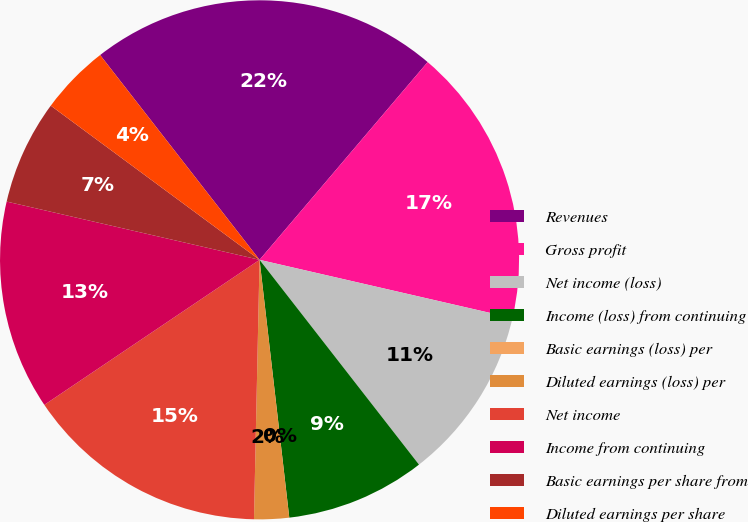Convert chart to OTSL. <chart><loc_0><loc_0><loc_500><loc_500><pie_chart><fcel>Revenues<fcel>Gross profit<fcel>Net income (loss)<fcel>Income (loss) from continuing<fcel>Basic earnings (loss) per<fcel>Diluted earnings (loss) per<fcel>Net income<fcel>Income from continuing<fcel>Basic earnings per share from<fcel>Diluted earnings per share<nl><fcel>21.74%<fcel>17.39%<fcel>10.87%<fcel>8.7%<fcel>0.0%<fcel>2.17%<fcel>15.22%<fcel>13.04%<fcel>6.52%<fcel>4.35%<nl></chart> 